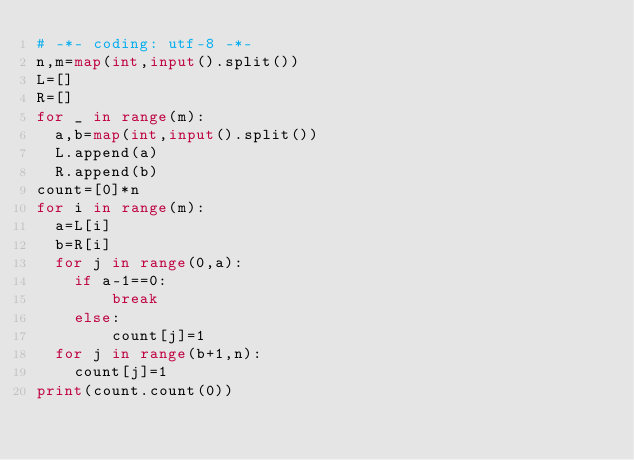Convert code to text. <code><loc_0><loc_0><loc_500><loc_500><_Python_># -*- coding: utf-8 -*-
n,m=map(int,input().split())
L=[]
R=[]
for _ in range(m):
  a,b=map(int,input().split())
  L.append(a)
  R.append(b)
count=[0]*n
for i in range(m):
  a=L[i]
  b=R[i]
  for j in range(0,a):
    if a-1==0:
        break
    else:
        count[j]=1
  for j in range(b+1,n):
    count[j]=1
print(count.count(0))</code> 